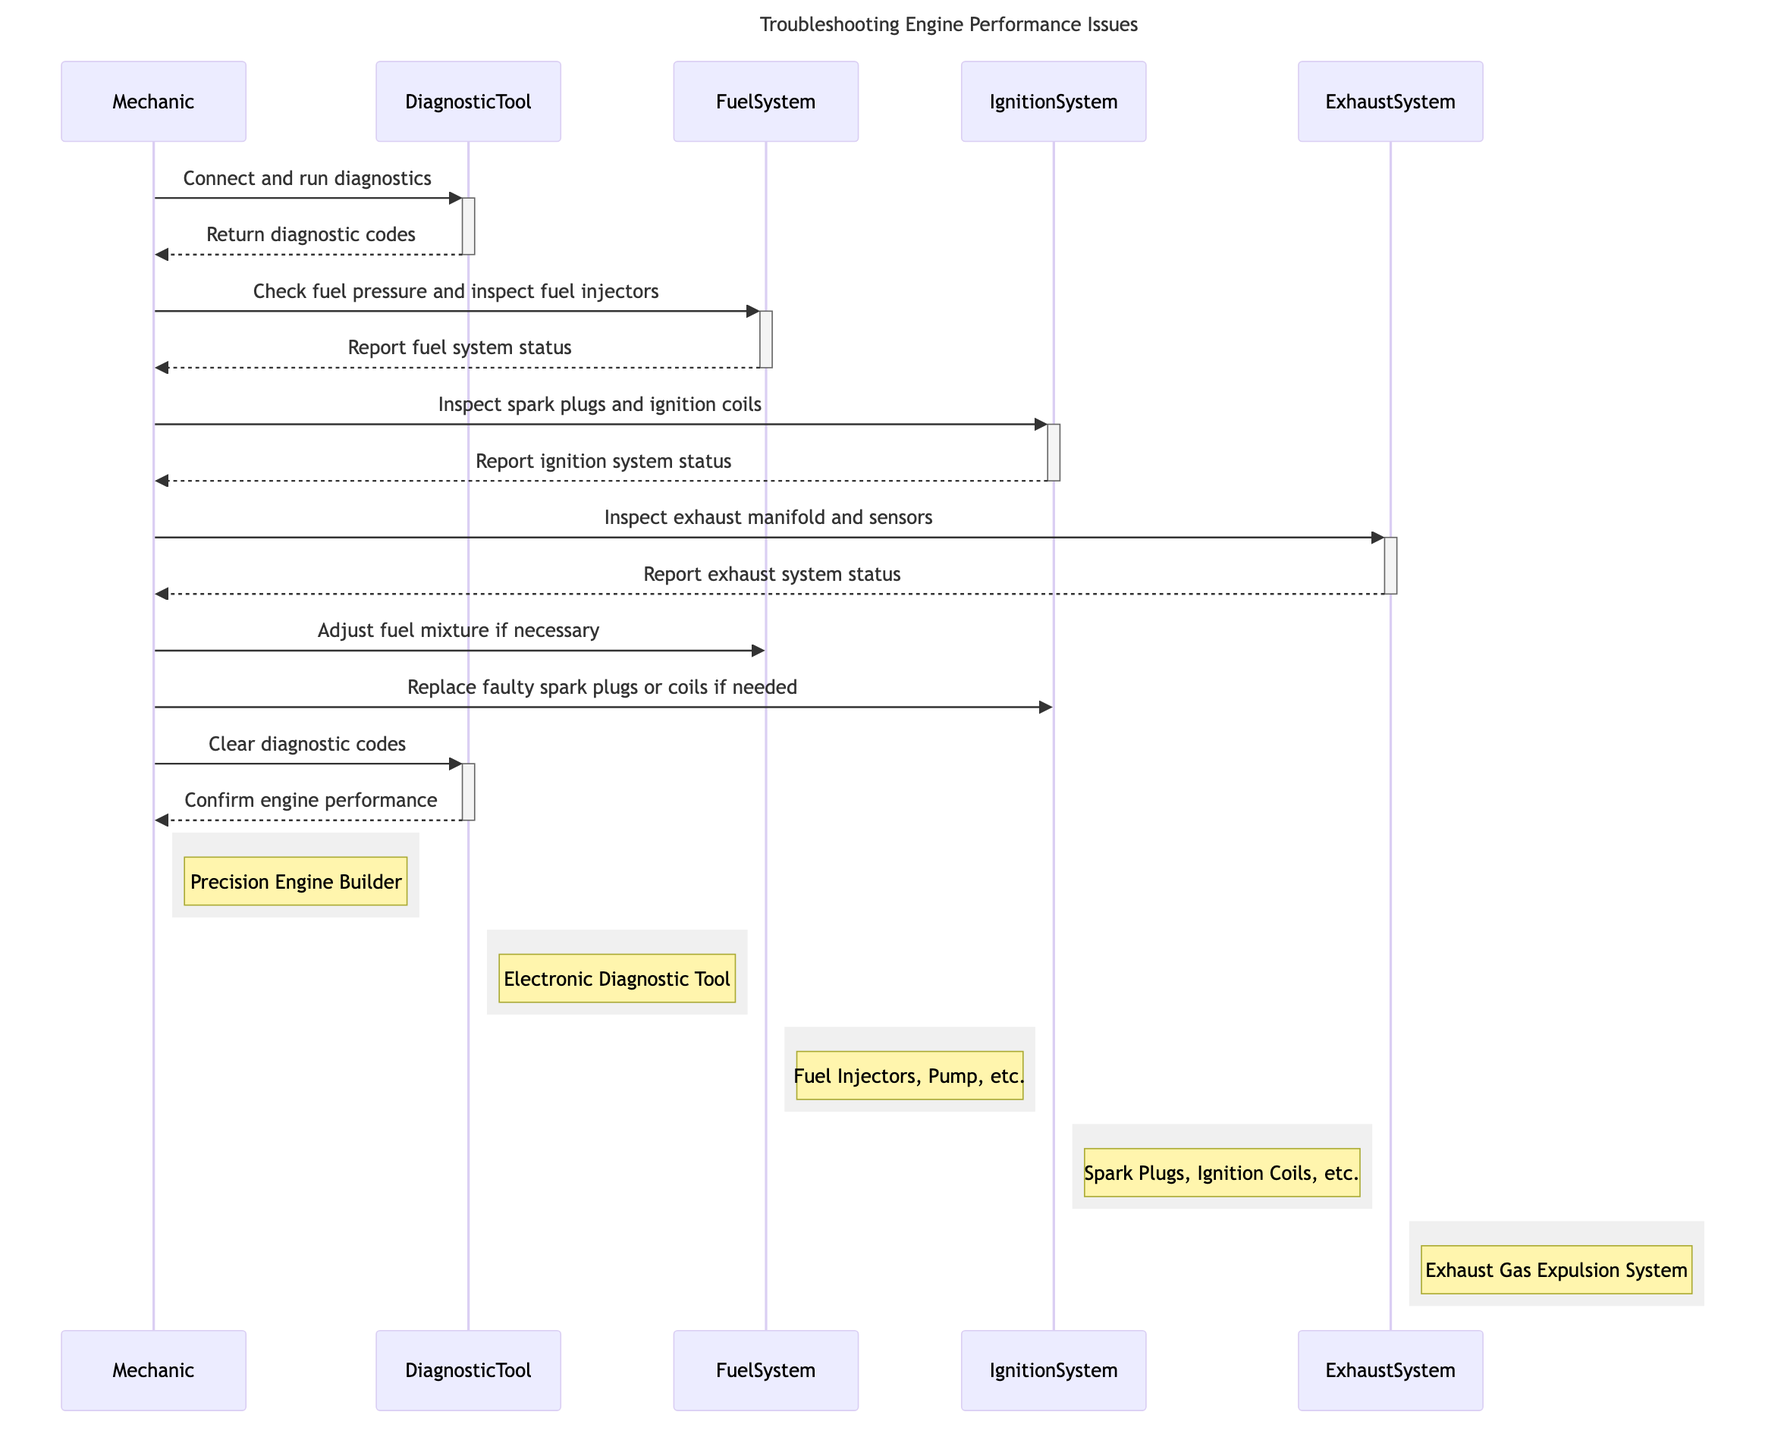What is the title of the diagram? The title of the diagram is explicitly given in the diagram code as "Troubleshooting Engine Performance Issues."
Answer: Troubleshooting Engine Performance Issues How many actors are involved in the diagram? By counting the entries listed under "actors," we see that there are five distinct actors: Mechanic, DiagnosticTool, FuelSystem, IgnitionSystem, and ExhaustSystem.
Answer: 5 Who does the Mechanic communicate with to run diagnostics? The first interaction shows that the Mechanic sends a message to the DiagnosticTool to connect and run diagnostics.
Answer: DiagnosticTool What message does the FuelSystem send back to the Mechanic? Following the Mechanic's request, the FuelSystem reports back with "Report fuel system status," which is a direct response to the inspection request.
Answer: Report fuel system status What action does the Mechanic take after checking the ExhaustSystem? After inspecting the ExhaustSystem, the Mechanic does not send a message regarding the inspection but rather communicates with the FuelSystem to potentially adjust the fuel mixture.
Answer: Adjust fuel mixture if necessary Which subsystem does the Mechanic inspect after the FuelSystem? After inspecting the FuelSystem, the Mechanic proceeds to inspect the IgnitionSystem, as indicated by the flow of messages moving from the FuelSystem to the IgnitionSystem.
Answer: IgnitionSystem What happens after the Mechanic clears the diagnostic codes? The final action taken by the Mechanic is sending a message to the DiagnosticTool to clear diagnostic codes, to which the DiagnosticTool responds by confirming engine performance.
Answer: Confirm engine performance How many total interactions (messages) are depicted in the diagram? By counting all the arrows representing communications between the actors, there are 12 messages exchanged in total throughout the troubleshooting process.
Answer: 12 What is the last subsystem the Mechanic inspects? The last subsystem inspected by the Mechanic is the ExhaustSystem, right after the IgnitionSystem is checked.
Answer: ExhaustSystem 